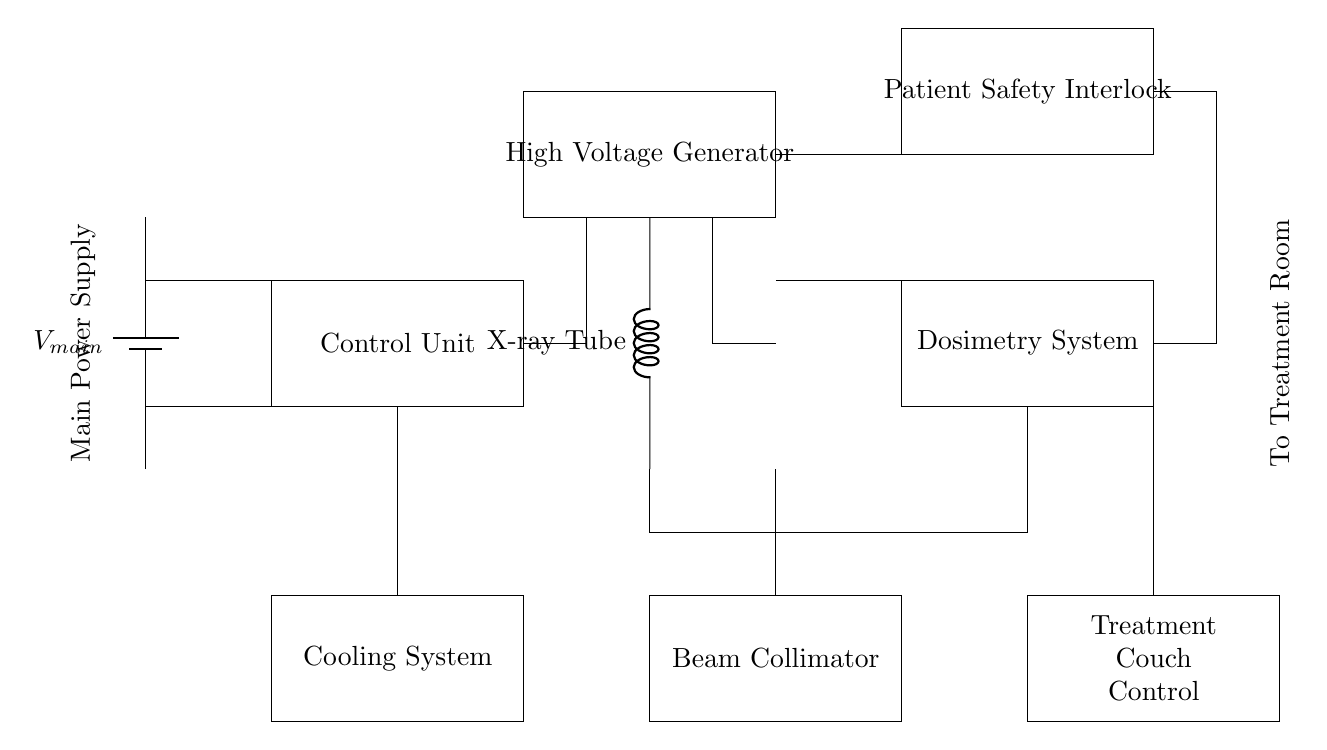what is the main power supply voltage marked in the circuit? The main power supply voltage is labeled as V main in the circuit diagram, indicating the potential difference supplied to the components.
Answer: V main what type of device is indicated as the high voltage generator? The high voltage generator is represented as a rectangle labeled High Voltage Generator, which is essential for providing the necessary voltage to the X-ray tube.
Answer: High Voltage Generator how many main components are there in the control unit? The control unit is depicted as a rectangle, and while specific internal components are not shown, it is usually responsible for processing signals and controls; thus, more context would be needed. However, it is one main component.
Answer: 1 what safety mechanism is included in the circuit? The patient safety interlock is highlighted as a rectangle labeled Patient Safety Interlock, indicating it is a critical feature for ensuring patient safety during treatment.
Answer: Patient Safety Interlock which system is responsible for measuring radiation dose? The system labeled Dosimetry System in the circuit diagram is responsible for measuring the amount of radiation delivered during therapy, ensuring accurate treatment delivery.
Answer: Dosimetry System explain how the cooling system is connected to the control unit and treatment components. The cooling system is connected to the control unit through a vertical line extending to the lower part, and this maintains an optimal temperature for the X-ray tube and other components by dissipating heat generated during operation.
Answer: Via a vertical connection what is the function of the beam collimator? The beam collimator, indicated as a rectangle in the diagram, is designed to shape the radiation beam, allowing precise targeting of the tumor while minimizing exposure to surrounding healthy tissues.
Answer: Shape radiation beam 